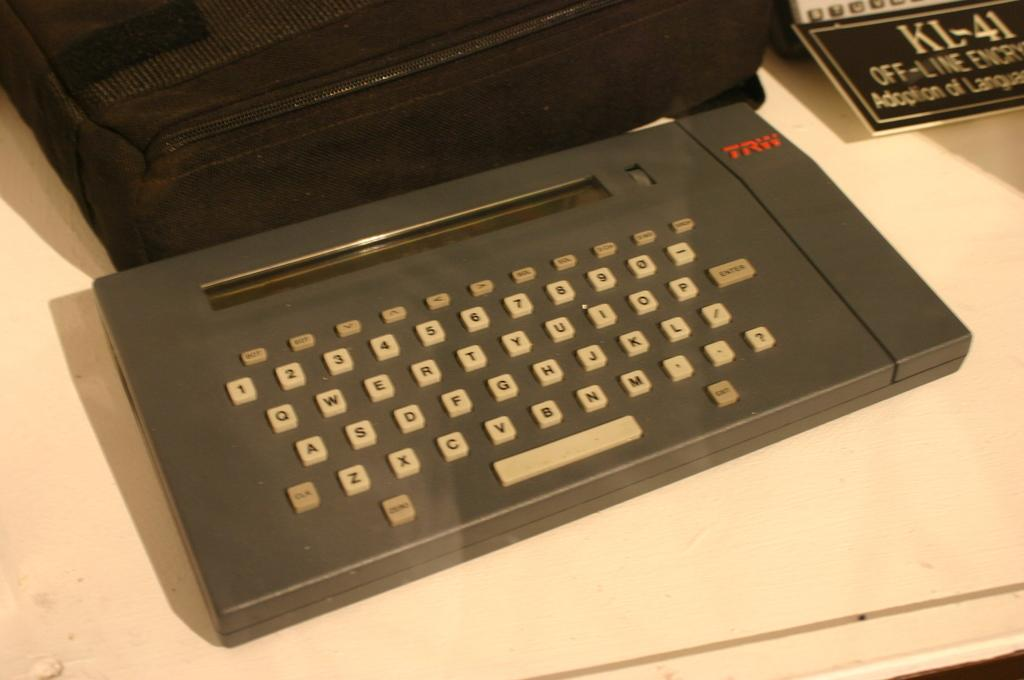<image>
Create a compact narrative representing the image presented. A TRW brand typewriter in front of a tv on a table. 